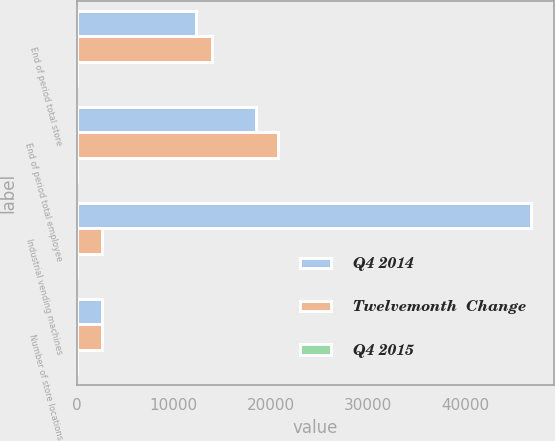Convert chart. <chart><loc_0><loc_0><loc_500><loc_500><stacked_bar_chart><ecel><fcel>End of period total store<fcel>End of period total employee<fcel>Industrial vending machines<fcel>Number of store locations<nl><fcel>Q4 2014<fcel>12293<fcel>18417<fcel>46855<fcel>2637<nl><fcel>Twelvemonth  Change<fcel>13961<fcel>20746<fcel>2637<fcel>2622<nl><fcel>Q4 2015<fcel>13.6<fcel>12.6<fcel>18.5<fcel>0.6<nl></chart> 